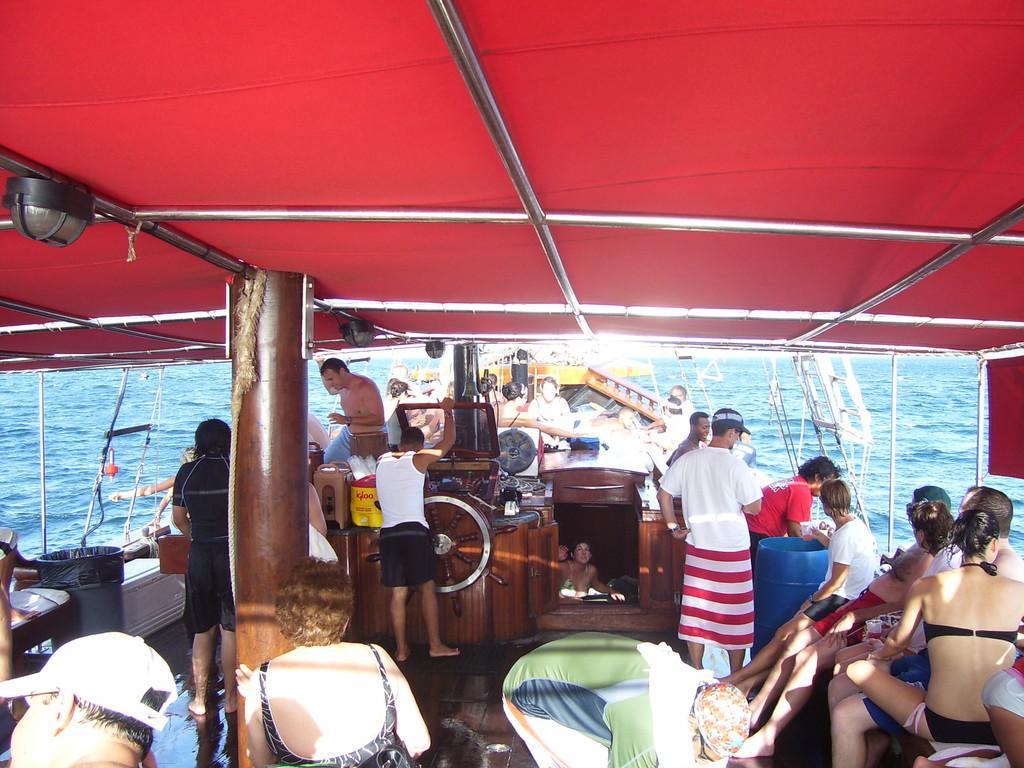In one or two sentences, can you explain what this image depicts? This image consists of many persons. They are sailing in the boat. At the bottom, there is water. The roof of the boat is in red color. 